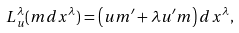Convert formula to latex. <formula><loc_0><loc_0><loc_500><loc_500>L _ { u } ^ { \lambda } ( m d x ^ { \lambda } ) = \left ( u m ^ { \prime } + \lambda u ^ { \prime } m \right ) d x ^ { \lambda } ,</formula> 